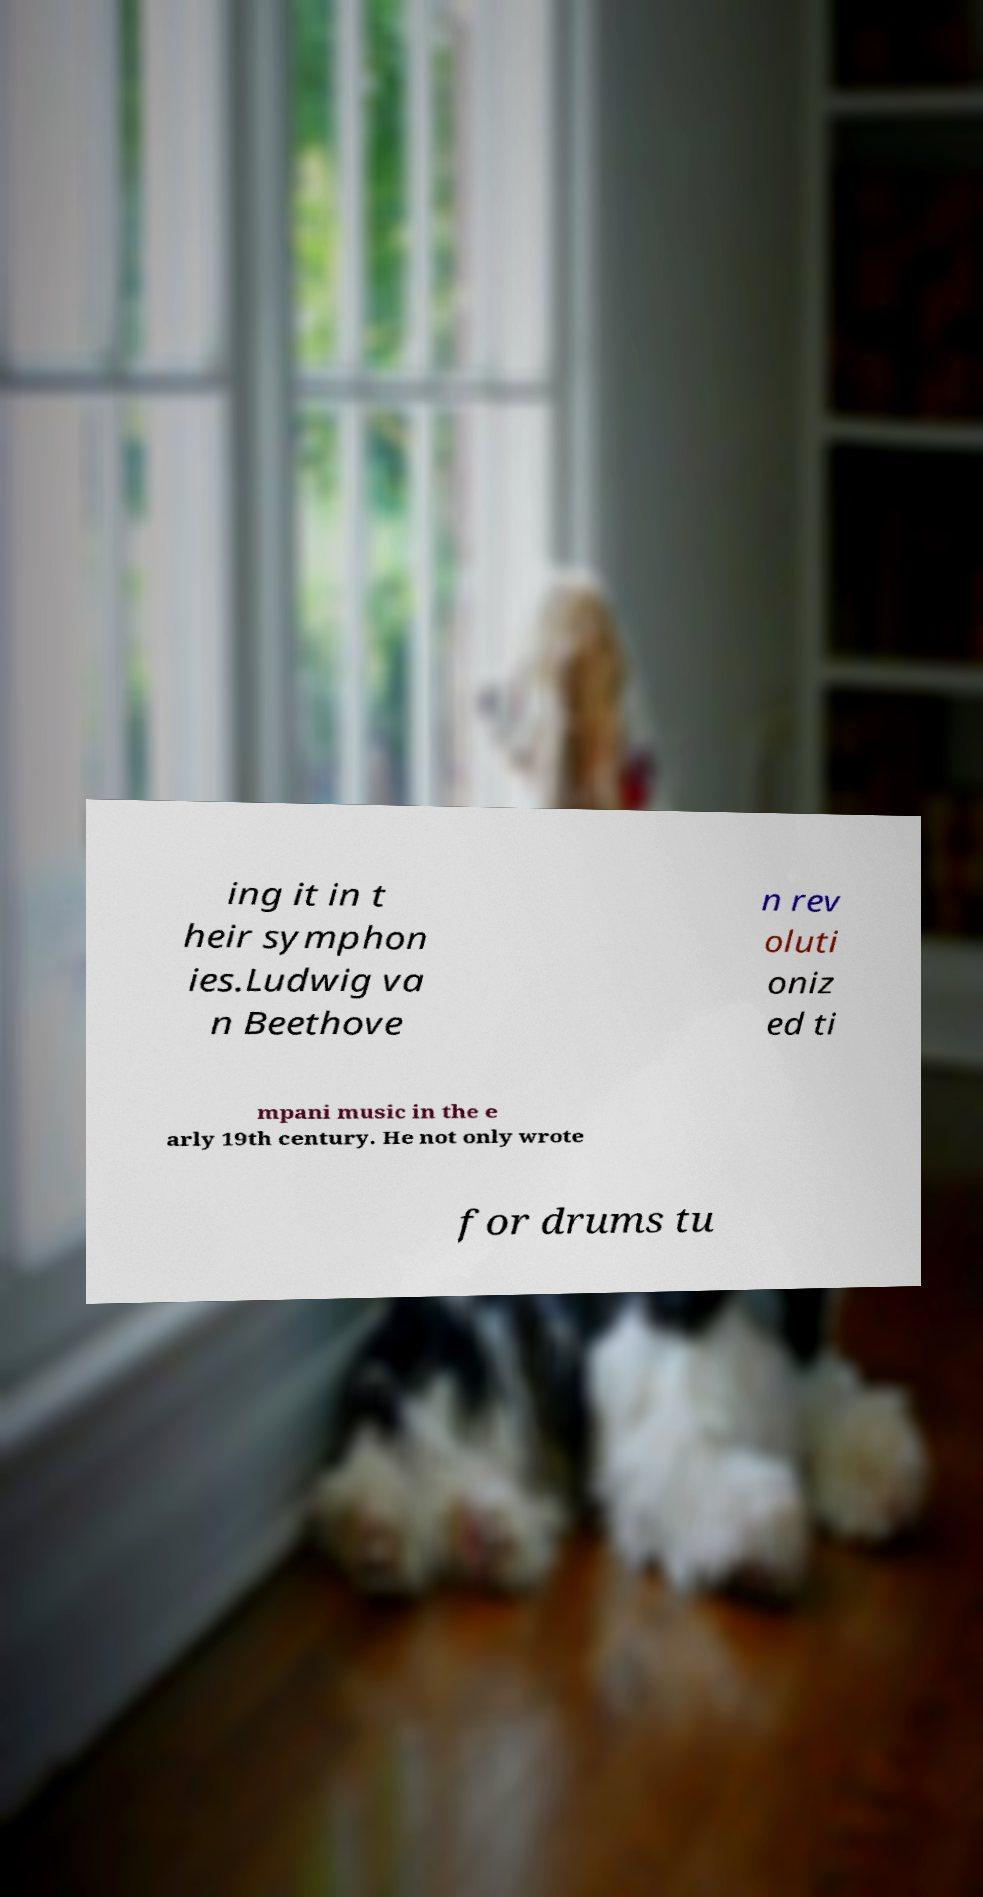Please identify and transcribe the text found in this image. ing it in t heir symphon ies.Ludwig va n Beethove n rev oluti oniz ed ti mpani music in the e arly 19th century. He not only wrote for drums tu 